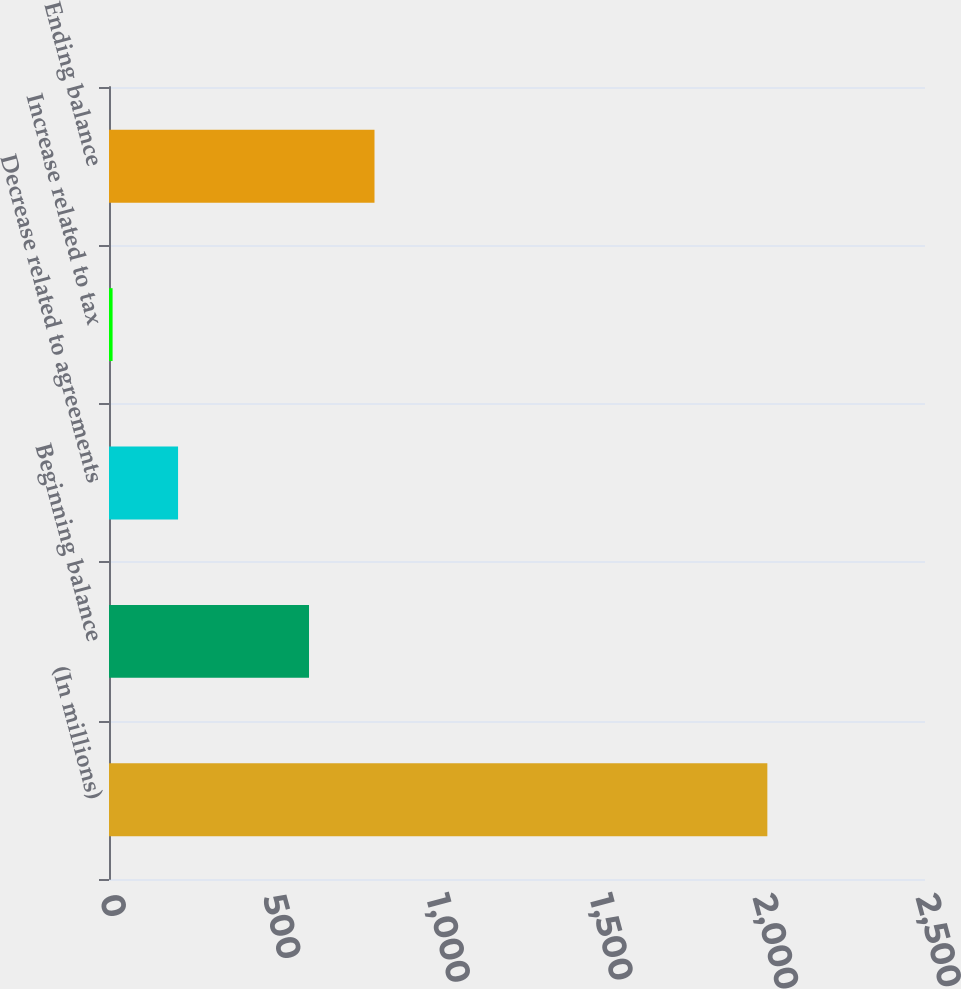<chart> <loc_0><loc_0><loc_500><loc_500><bar_chart><fcel>(In millions)<fcel>Beginning balance<fcel>Decrease related to agreements<fcel>Increase related to tax<fcel>Ending balance<nl><fcel>2017<fcel>612.8<fcel>211.6<fcel>11<fcel>813.4<nl></chart> 